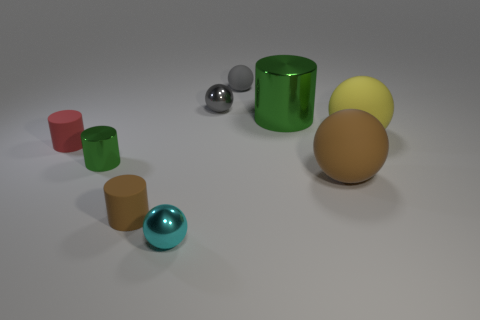Is the color of the big metallic cylinder the same as the shiny cylinder on the left side of the cyan shiny thing? Yes, the color of the large metallic green cylinder is indeed the same as the smaller shiny green cylinder that's located to the left of the cyan-colored sphere. Both exhibit a similar hue and glossy surface, indicating that they share the same color. 